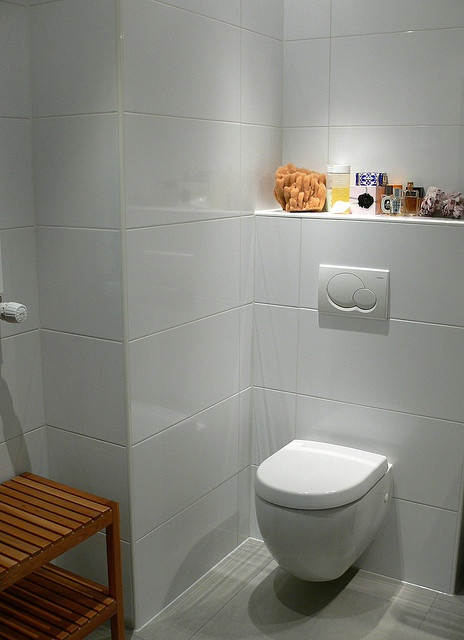Describe the objects in this image and their specific colors. I can see a toilet in gray, lightgray, and darkgray tones in this image. 